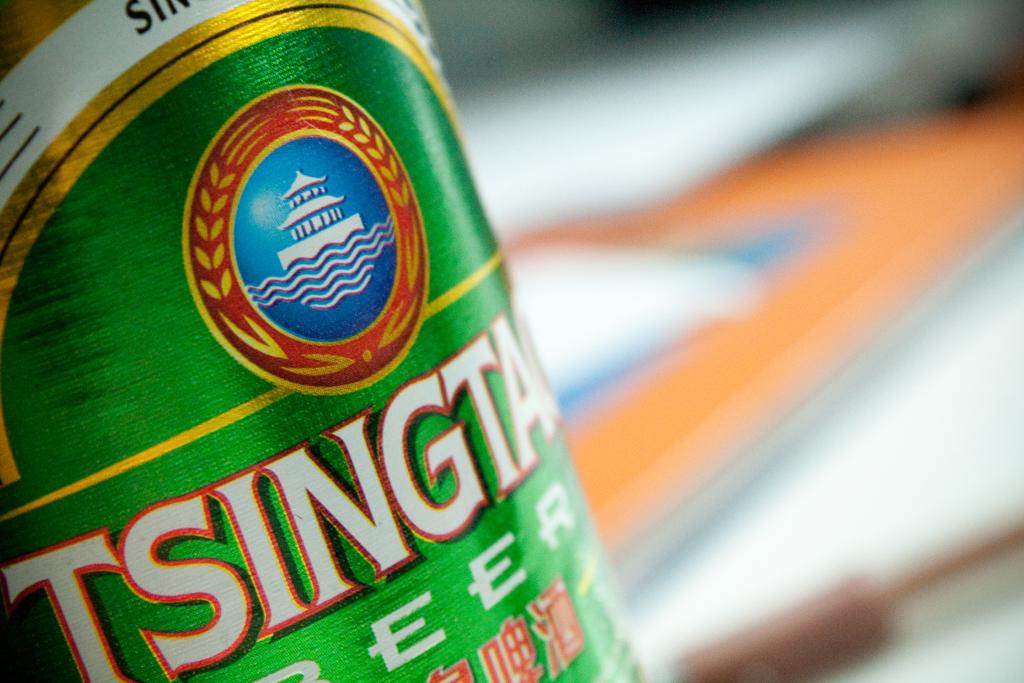<image>
Write a terse but informative summary of the picture. A green bottle of beer that says Tsingtao. 